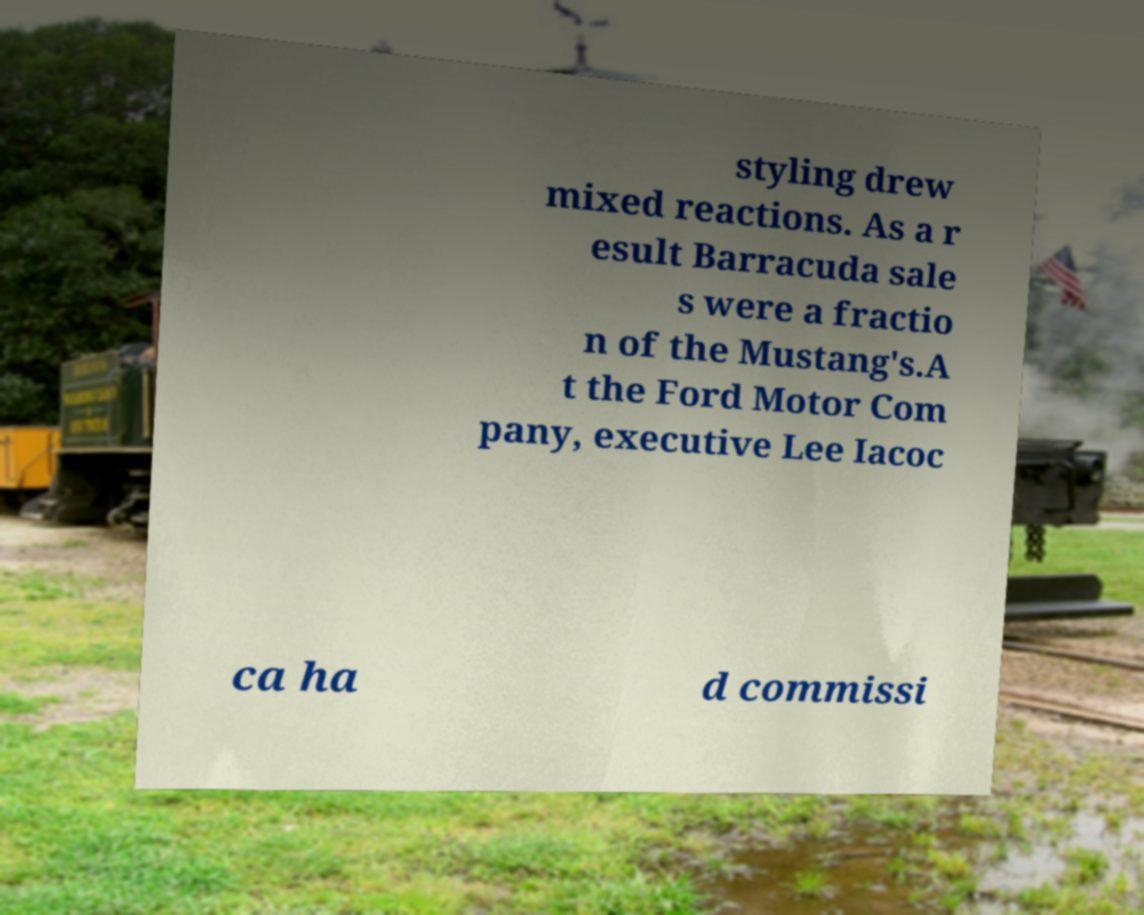What messages or text are displayed in this image? I need them in a readable, typed format. styling drew mixed reactions. As a r esult Barracuda sale s were a fractio n of the Mustang's.A t the Ford Motor Com pany, executive Lee Iacoc ca ha d commissi 